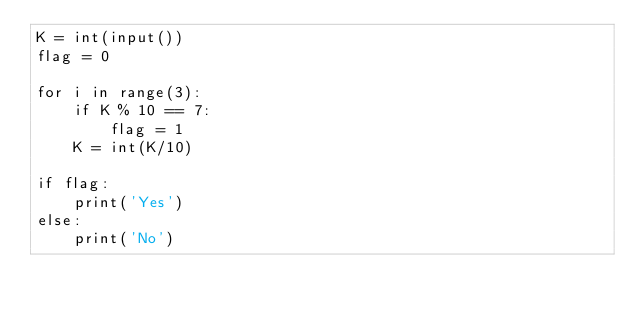<code> <loc_0><loc_0><loc_500><loc_500><_Python_>K = int(input())
flag = 0

for i in range(3):
    if K % 10 == 7:
        flag = 1
    K = int(K/10)
    
if flag:
    print('Yes')
else:
    print('No')</code> 